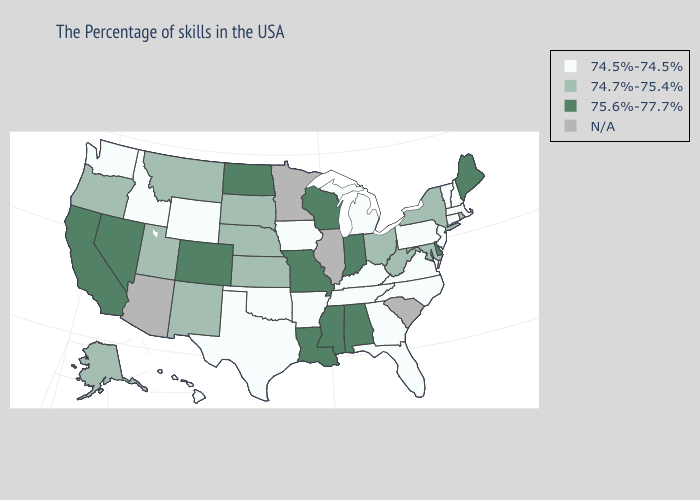Which states have the lowest value in the USA?
Be succinct. Massachusetts, New Hampshire, Vermont, Connecticut, New Jersey, Pennsylvania, Virginia, North Carolina, Florida, Georgia, Michigan, Kentucky, Tennessee, Arkansas, Iowa, Oklahoma, Texas, Wyoming, Idaho, Washington, Hawaii. Is the legend a continuous bar?
Give a very brief answer. No. Name the states that have a value in the range 75.6%-77.7%?
Write a very short answer. Maine, Delaware, Indiana, Alabama, Wisconsin, Mississippi, Louisiana, Missouri, North Dakota, Colorado, Nevada, California. Among the states that border Oregon , which have the highest value?
Write a very short answer. Nevada, California. Does Maine have the highest value in the Northeast?
Quick response, please. Yes. What is the highest value in states that border Indiana?
Write a very short answer. 74.7%-75.4%. Name the states that have a value in the range 74.7%-75.4%?
Quick response, please. Rhode Island, New York, Maryland, West Virginia, Ohio, Kansas, Nebraska, South Dakota, New Mexico, Utah, Montana, Oregon, Alaska. What is the value of New Jersey?
Keep it brief. 74.5%-74.5%. What is the highest value in states that border Ohio?
Give a very brief answer. 75.6%-77.7%. Does Maine have the highest value in the Northeast?
Write a very short answer. Yes. Name the states that have a value in the range N/A?
Answer briefly. South Carolina, Illinois, Minnesota, Arizona. What is the value of Pennsylvania?
Be succinct. 74.5%-74.5%. Does Georgia have the lowest value in the USA?
Answer briefly. Yes. Which states have the lowest value in the USA?
Be succinct. Massachusetts, New Hampshire, Vermont, Connecticut, New Jersey, Pennsylvania, Virginia, North Carolina, Florida, Georgia, Michigan, Kentucky, Tennessee, Arkansas, Iowa, Oklahoma, Texas, Wyoming, Idaho, Washington, Hawaii. 